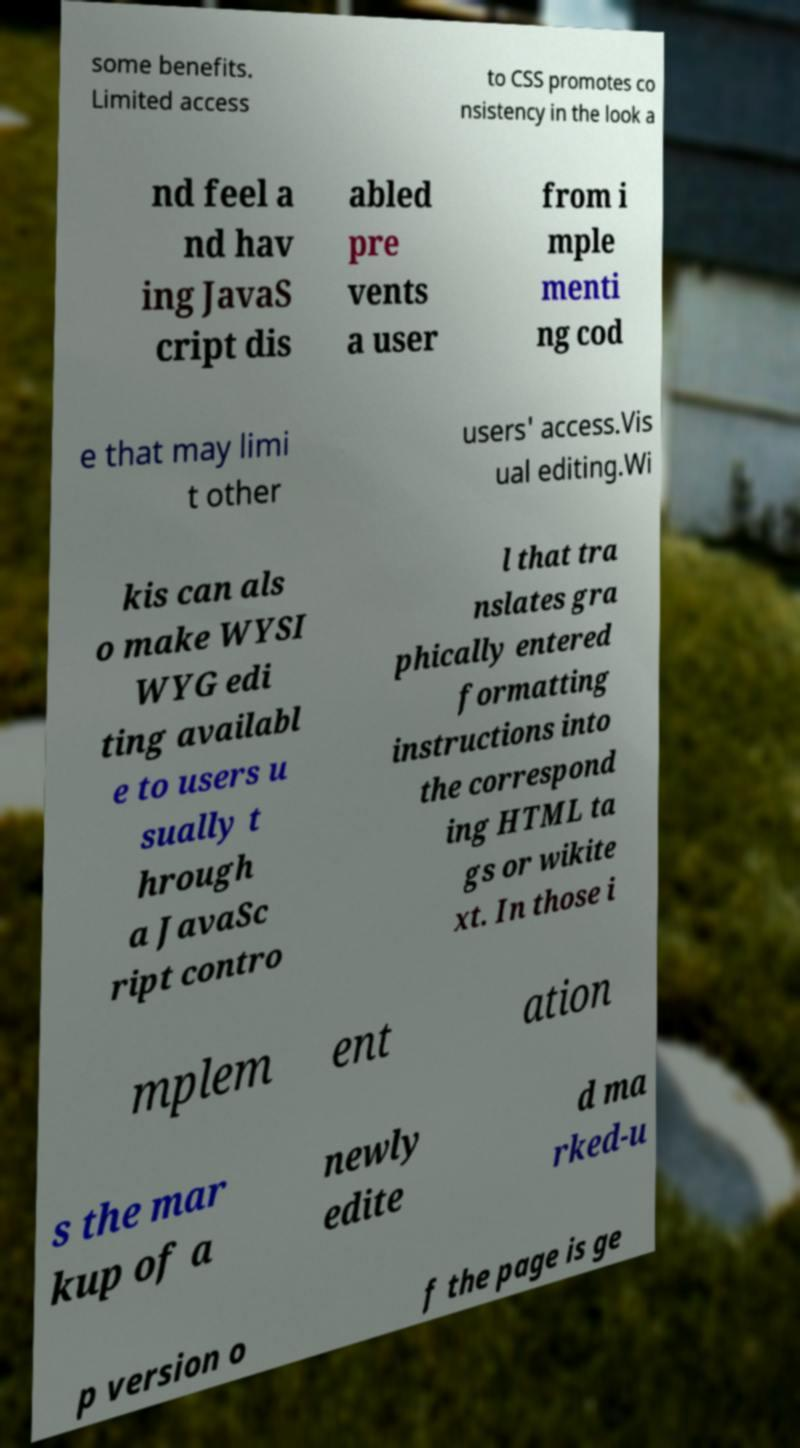Could you assist in decoding the text presented in this image and type it out clearly? some benefits. Limited access to CSS promotes co nsistency in the look a nd feel a nd hav ing JavaS cript dis abled pre vents a user from i mple menti ng cod e that may limi t other users' access.Vis ual editing.Wi kis can als o make WYSI WYG edi ting availabl e to users u sually t hrough a JavaSc ript contro l that tra nslates gra phically entered formatting instructions into the correspond ing HTML ta gs or wikite xt. In those i mplem ent ation s the mar kup of a newly edite d ma rked-u p version o f the page is ge 